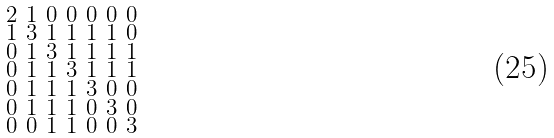<formula> <loc_0><loc_0><loc_500><loc_500>\begin{smallmatrix} 2 & 1 & 0 & 0 & 0 & 0 & 0 \\ 1 & 3 & 1 & 1 & 1 & 1 & 0 \\ 0 & 1 & 3 & 1 & 1 & 1 & 1 \\ 0 & 1 & 1 & 3 & 1 & 1 & 1 \\ 0 & 1 & 1 & 1 & 3 & 0 & 0 \\ 0 & 1 & 1 & 1 & 0 & 3 & 0 \\ 0 & 0 & 1 & 1 & 0 & 0 & 3 \end{smallmatrix}</formula> 